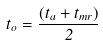<formula> <loc_0><loc_0><loc_500><loc_500>t _ { o } = \frac { ( t _ { a } + t _ { m r } ) } { 2 }</formula> 